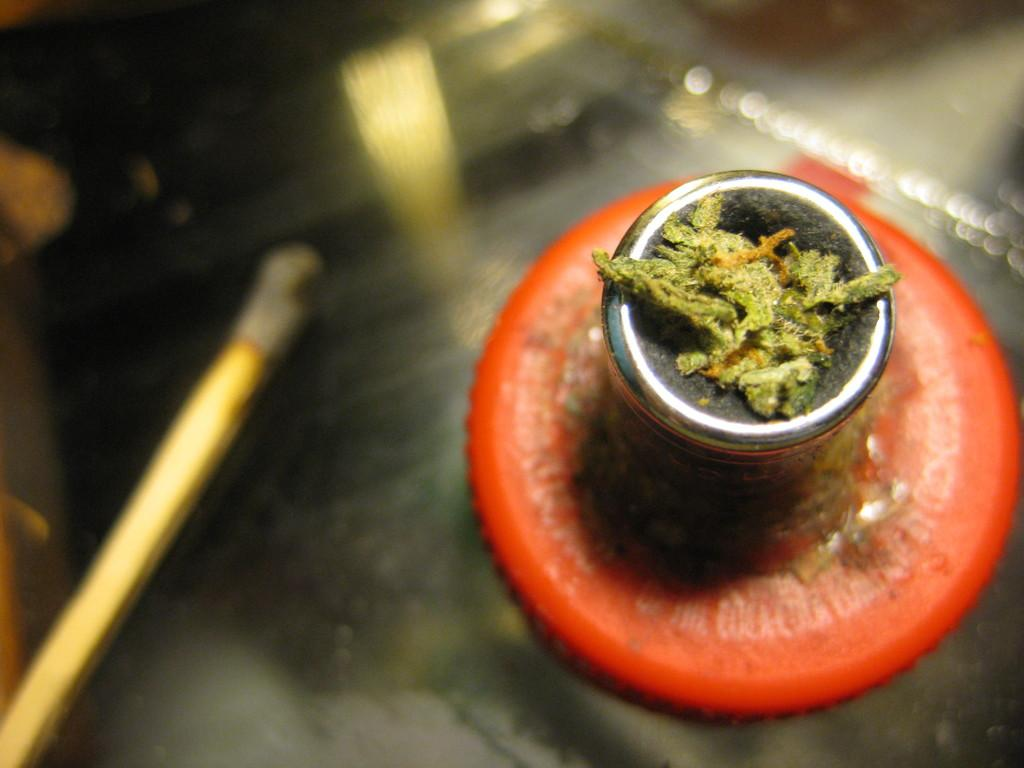What piece of furniture is present in the image? There is a table in the image. What objects are placed on the table? There is a glass on a plate in the image. How does the glass increase in size in the image? The glass does not increase in size in the image; it remains the same size throughout the image. 